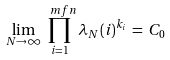Convert formula to latex. <formula><loc_0><loc_0><loc_500><loc_500>\lim _ { N \to \infty } \prod _ { i = 1 } ^ { \ m f n } \lambda _ { N } ( i ) ^ { k _ { i } } \, = \, C _ { 0 }</formula> 